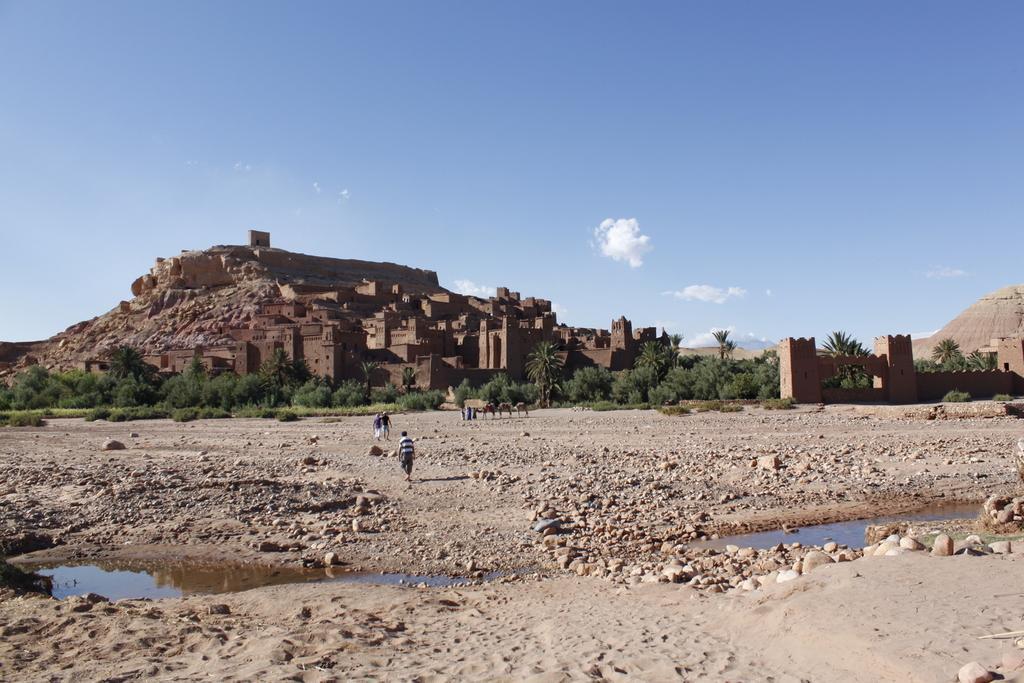In one or two sentences, can you explain what this image depicts? This picture consists of fort , in front of fort there are some trees , land, on the I can see water, some peoples walking in front of fort at the top there is the sky. 